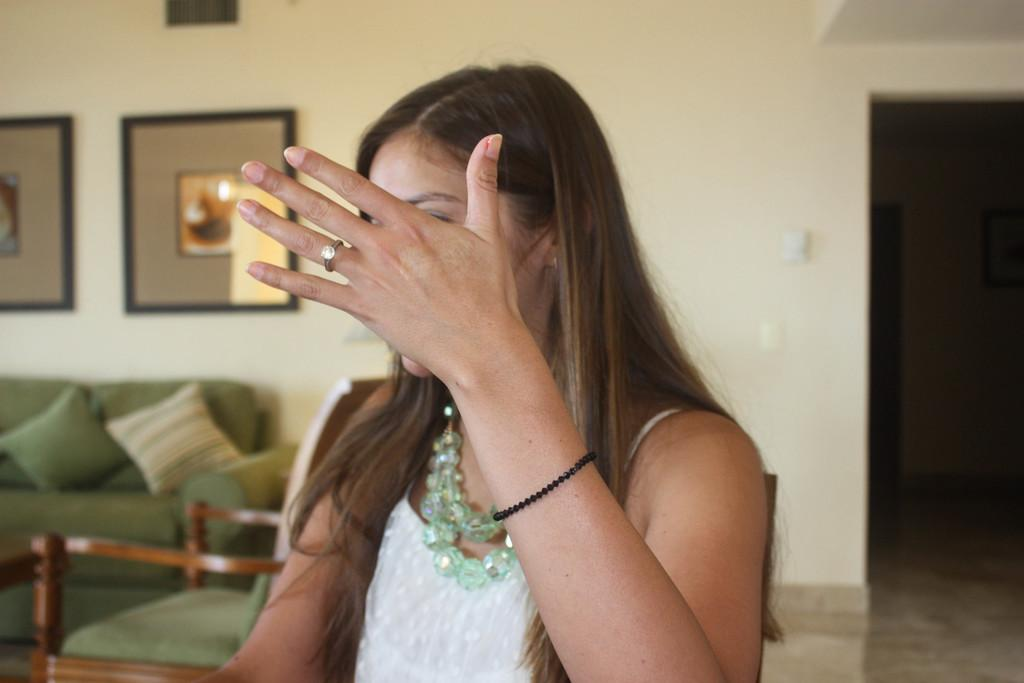Who is present in the image? There is a woman in the image. What is the woman doing with her hand? The woman is hiding her face with her hand. What can be seen in the background of the image? There is a sofa and a photograph on the wall in the background. Where is the switch located in the image? The switch is on the right side of the image. How many soldiers are present in the image? There are no soldiers or army-related elements present in the image. What type of table is visible in the image? There is no table visible in the image. 